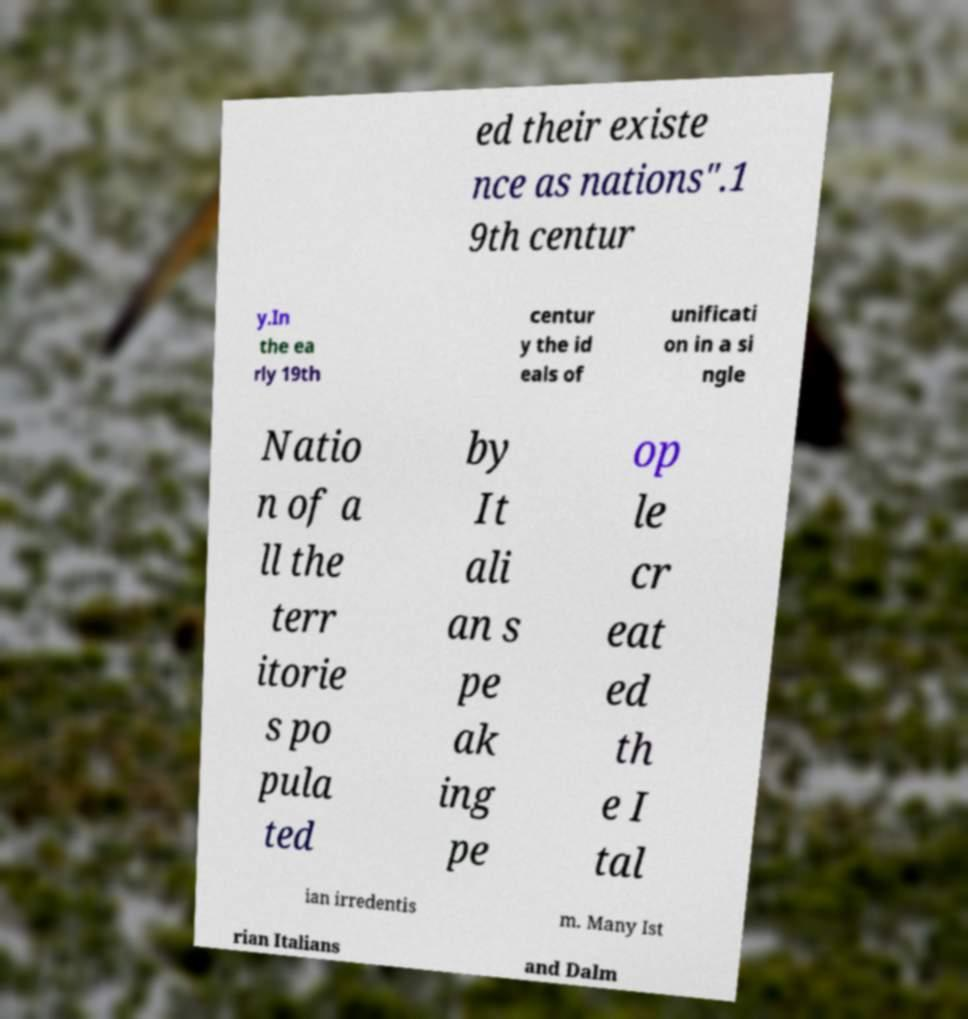There's text embedded in this image that I need extracted. Can you transcribe it verbatim? ed their existe nce as nations".1 9th centur y.In the ea rly 19th centur y the id eals of unificati on in a si ngle Natio n of a ll the terr itorie s po pula ted by It ali an s pe ak ing pe op le cr eat ed th e I tal ian irredentis m. Many Ist rian Italians and Dalm 